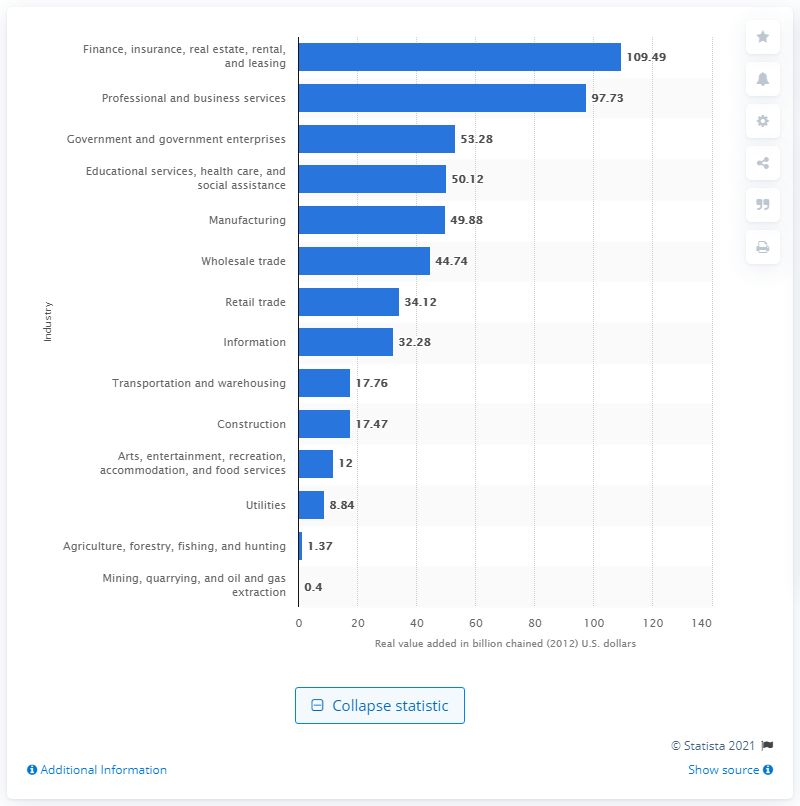Identify some key points in this picture. The mining industry added 0.4% to the state's GDP in 2012. 